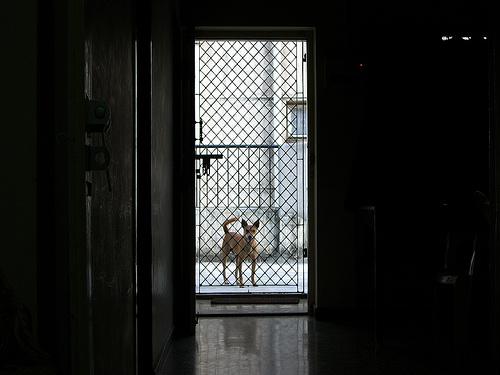Is this a chain link fence?
Concise answer only. Yes. What sort of home do the neighbors have?
Concise answer only. Apartment. What kind of animal is that?
Give a very brief answer. Dog. What is the dog looking out of?
Keep it brief. Door. Which direction is the dog facing?
Be succinct. Front. Is the dog angry?
Keep it brief. No. Would the animal be more likely to eat tuna fish or gnaw a steak bone?
Be succinct. Steak bone. What is outside the door?
Be succinct. Dog. Would someone be able to see his reflection in here?
Short answer required. No. How many dogs are there?
Give a very brief answer. 1. Is this a zoo?
Write a very short answer. No. What is in front of the bike?
Keep it brief. Dog. What is the animal in this photo?
Short answer required. Dog. Is that a chair outside?
Answer briefly. No. Is it morning or afternoon?
Give a very brief answer. Morning. What room is this?
Give a very brief answer. Kitchen. Is the cat outside the door?
Concise answer only. Yes. Which animal is it?
Give a very brief answer. Dog. Is there a water animal in this picture?
Give a very brief answer. No. Is the door insulated?
Quick response, please. No. Where was this taken?
Keep it brief. Inside. Are there any lights on in this image?
Quick response, please. No. Is this dog most likely to be a purebred or a mutt?
Answer briefly. Mutt. What is visible straight ahead?
Write a very short answer. Dog. Where is the light coming from?
Short answer required. Outside. Where is the animal being kept?
Be succinct. Outside. Is the dog playing?
Answer briefly. No. How many windows are there?
Short answer required. 0. What is the door made of?
Quick response, please. Metal. What is looking into the window?
Answer briefly. Dog. What time of the day is it?
Short answer required. Noon. Is there a fence?
Write a very short answer. Yes. 